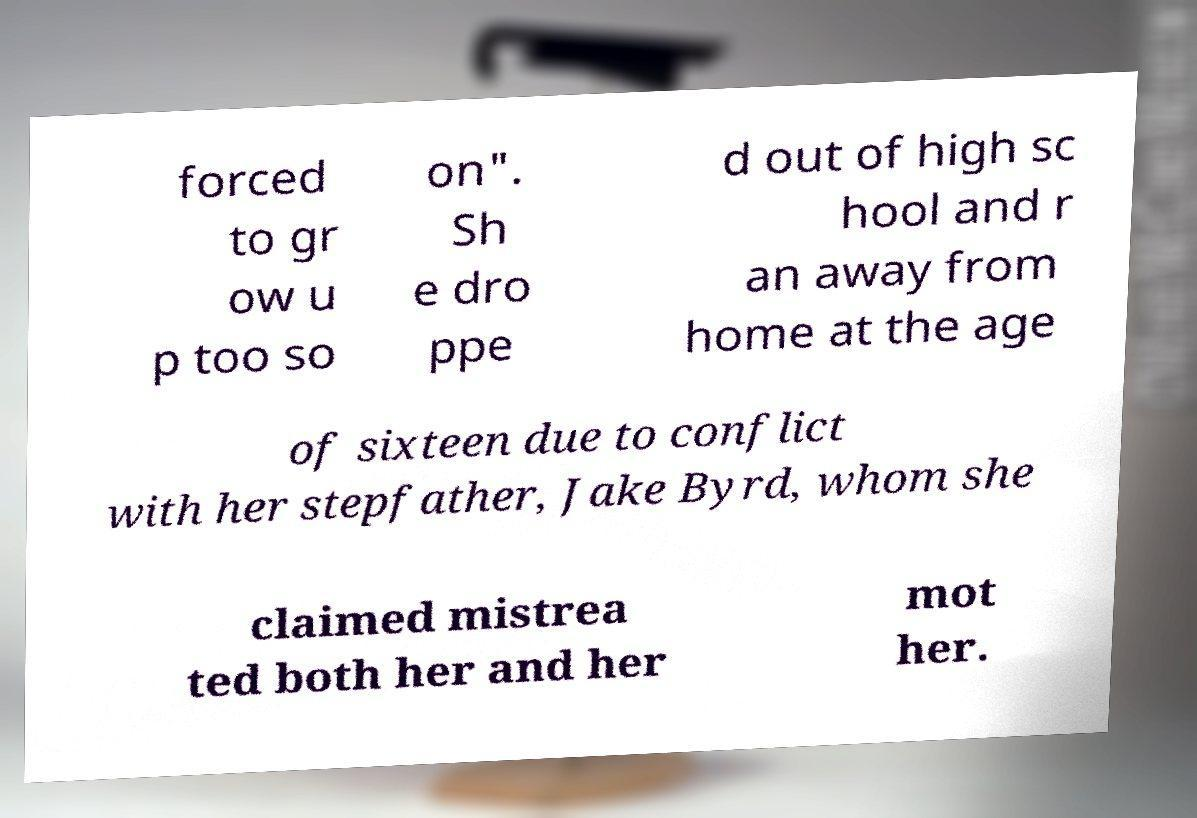Please read and relay the text visible in this image. What does it say? forced to gr ow u p too so on". Sh e dro ppe d out of high sc hool and r an away from home at the age of sixteen due to conflict with her stepfather, Jake Byrd, whom she claimed mistrea ted both her and her mot her. 